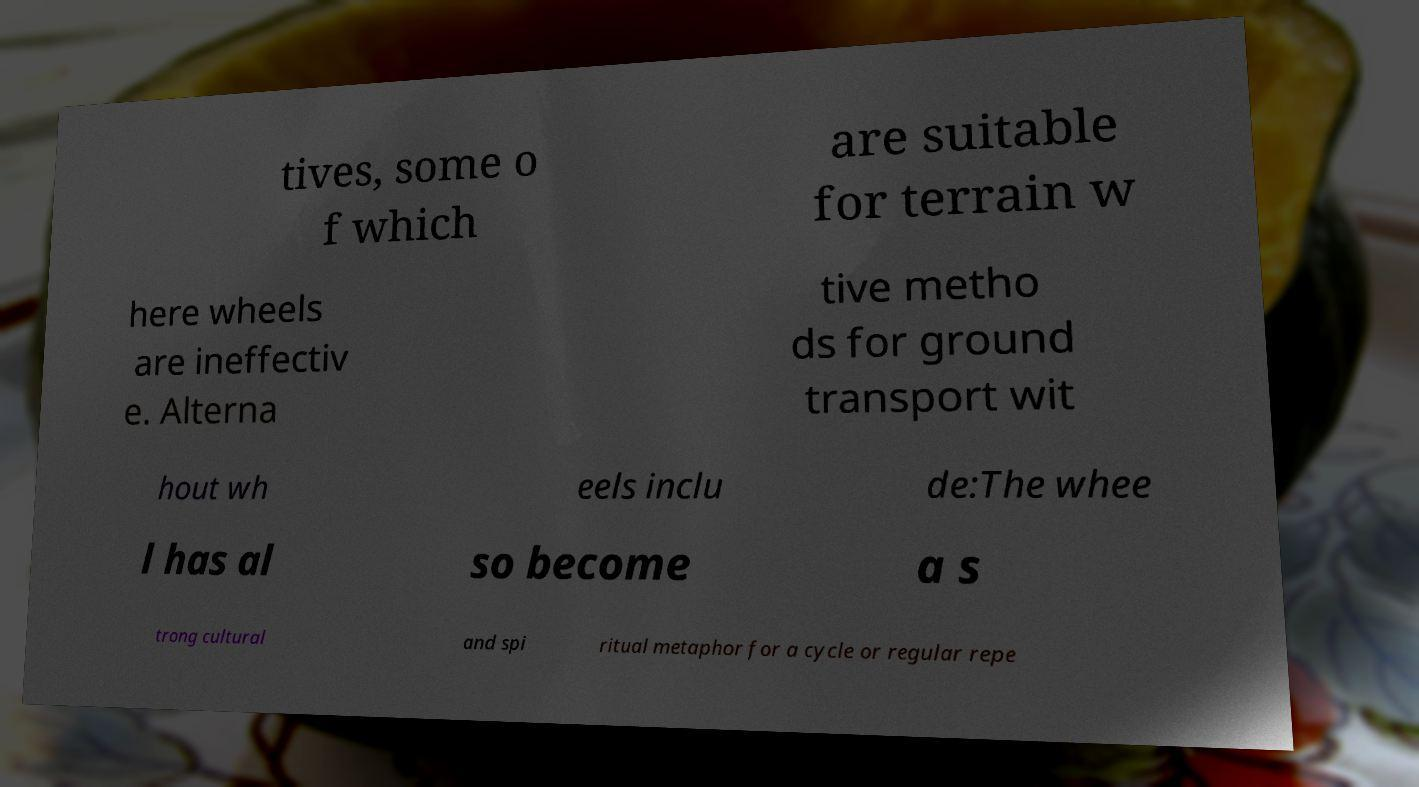Could you extract and type out the text from this image? tives, some o f which are suitable for terrain w here wheels are ineffectiv e. Alterna tive metho ds for ground transport wit hout wh eels inclu de:The whee l has al so become a s trong cultural and spi ritual metaphor for a cycle or regular repe 